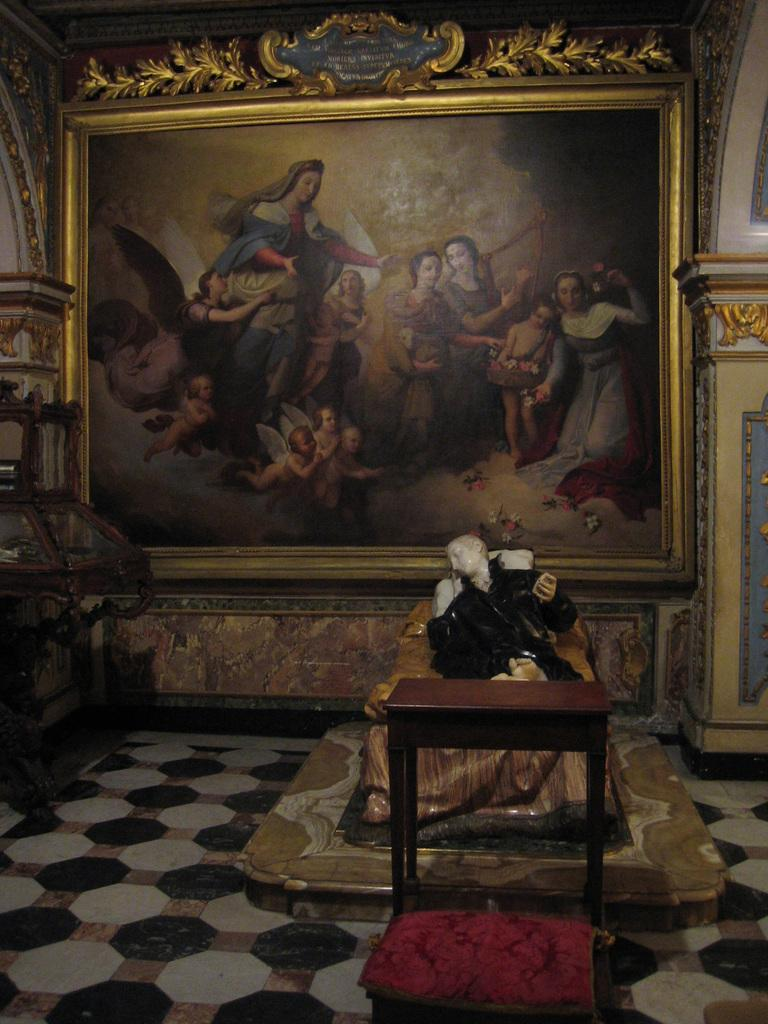What is the main subject of the image? There is a sculpture of a person laying on a bed in the image. What other objects can be seen in the image? There is a table and a stool in the image. What is present on the wall in the background of the image? There is a big frame attached to the wall in the background of the image. What type of oil is being used to clean the sculpture in the image? There is no oil or cleaning activity depicted in the image; it features a sculpture of a person laying on a bed, a table, a stool, and a big frame on the wall. 